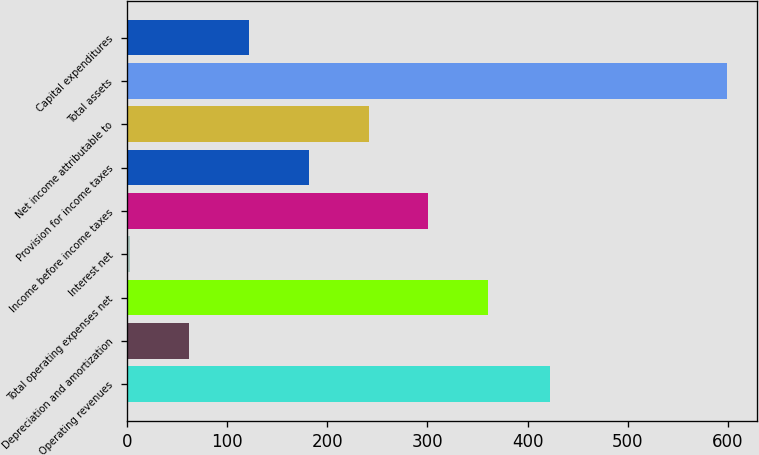Convert chart to OTSL. <chart><loc_0><loc_0><loc_500><loc_500><bar_chart><fcel>Operating revenues<fcel>Depreciation and amortization<fcel>Total operating expenses net<fcel>Interest net<fcel>Income before income taxes<fcel>Provision for income taxes<fcel>Net income attributable to<fcel>Total assets<fcel>Capital expenditures<nl><fcel>422<fcel>62.6<fcel>360.6<fcel>3<fcel>301<fcel>181.8<fcel>241.4<fcel>599<fcel>122.2<nl></chart> 